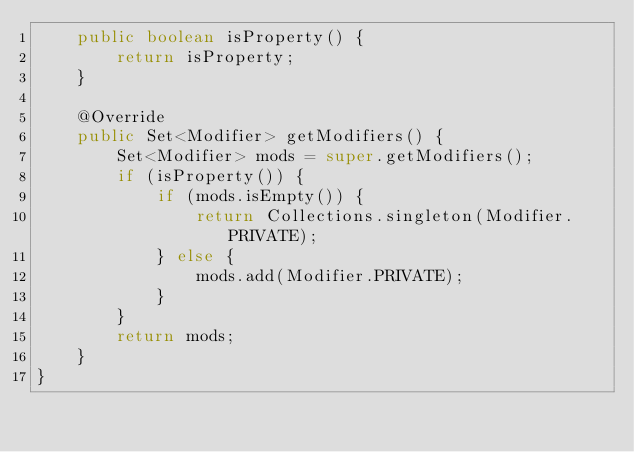Convert code to text. <code><loc_0><loc_0><loc_500><loc_500><_Java_>    public boolean isProperty() {
        return isProperty;
    }

    @Override
    public Set<Modifier> getModifiers() {
        Set<Modifier> mods = super.getModifiers();
        if (isProperty()) {
            if (mods.isEmpty()) {
                return Collections.singleton(Modifier.PRIVATE);
            } else {
                mods.add(Modifier.PRIVATE);
            }
        }
        return mods;
    }
}
</code> 